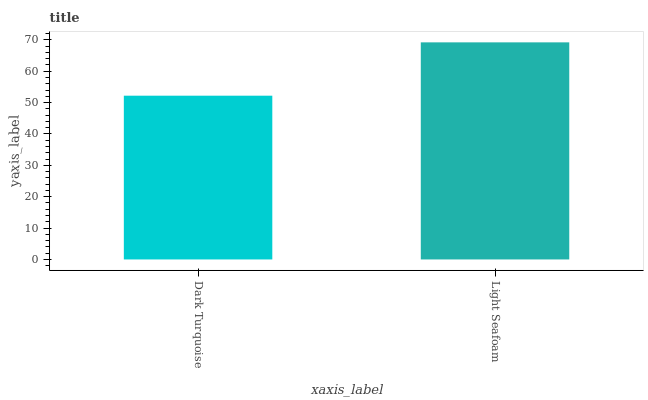Is Dark Turquoise the minimum?
Answer yes or no. Yes. Is Light Seafoam the maximum?
Answer yes or no. Yes. Is Light Seafoam the minimum?
Answer yes or no. No. Is Light Seafoam greater than Dark Turquoise?
Answer yes or no. Yes. Is Dark Turquoise less than Light Seafoam?
Answer yes or no. Yes. Is Dark Turquoise greater than Light Seafoam?
Answer yes or no. No. Is Light Seafoam less than Dark Turquoise?
Answer yes or no. No. Is Light Seafoam the high median?
Answer yes or no. Yes. Is Dark Turquoise the low median?
Answer yes or no. Yes. Is Dark Turquoise the high median?
Answer yes or no. No. Is Light Seafoam the low median?
Answer yes or no. No. 